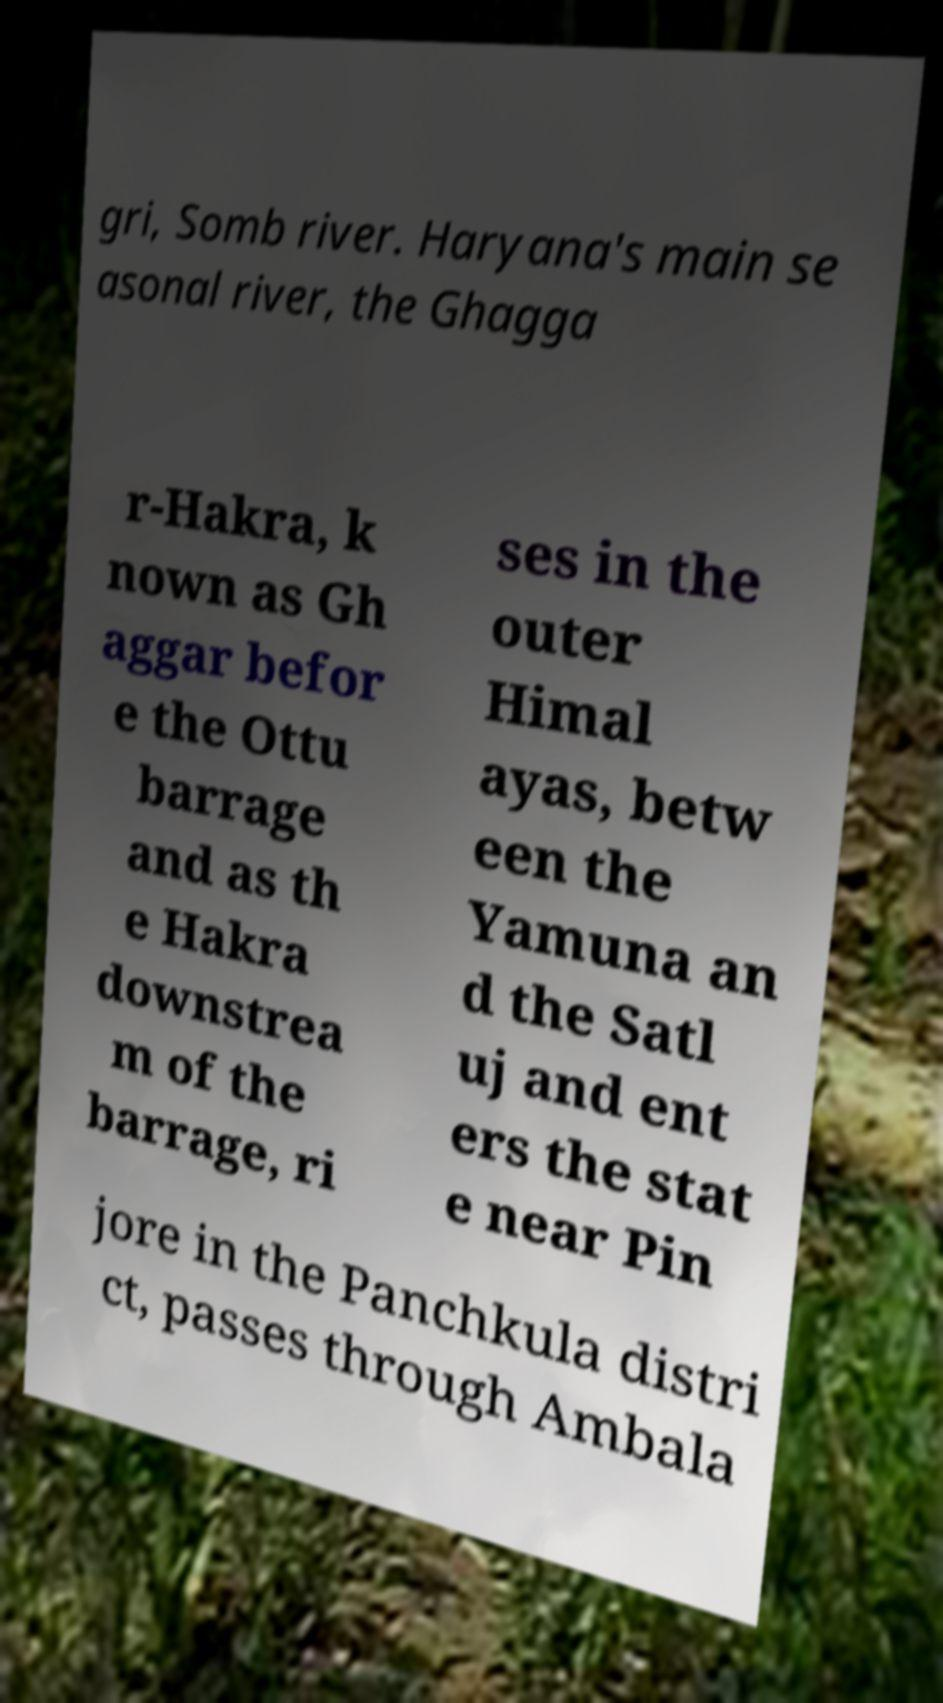I need the written content from this picture converted into text. Can you do that? gri, Somb river. Haryana's main se asonal river, the Ghagga r-Hakra, k nown as Gh aggar befor e the Ottu barrage and as th e Hakra downstrea m of the barrage, ri ses in the outer Himal ayas, betw een the Yamuna an d the Satl uj and ent ers the stat e near Pin jore in the Panchkula distri ct, passes through Ambala 